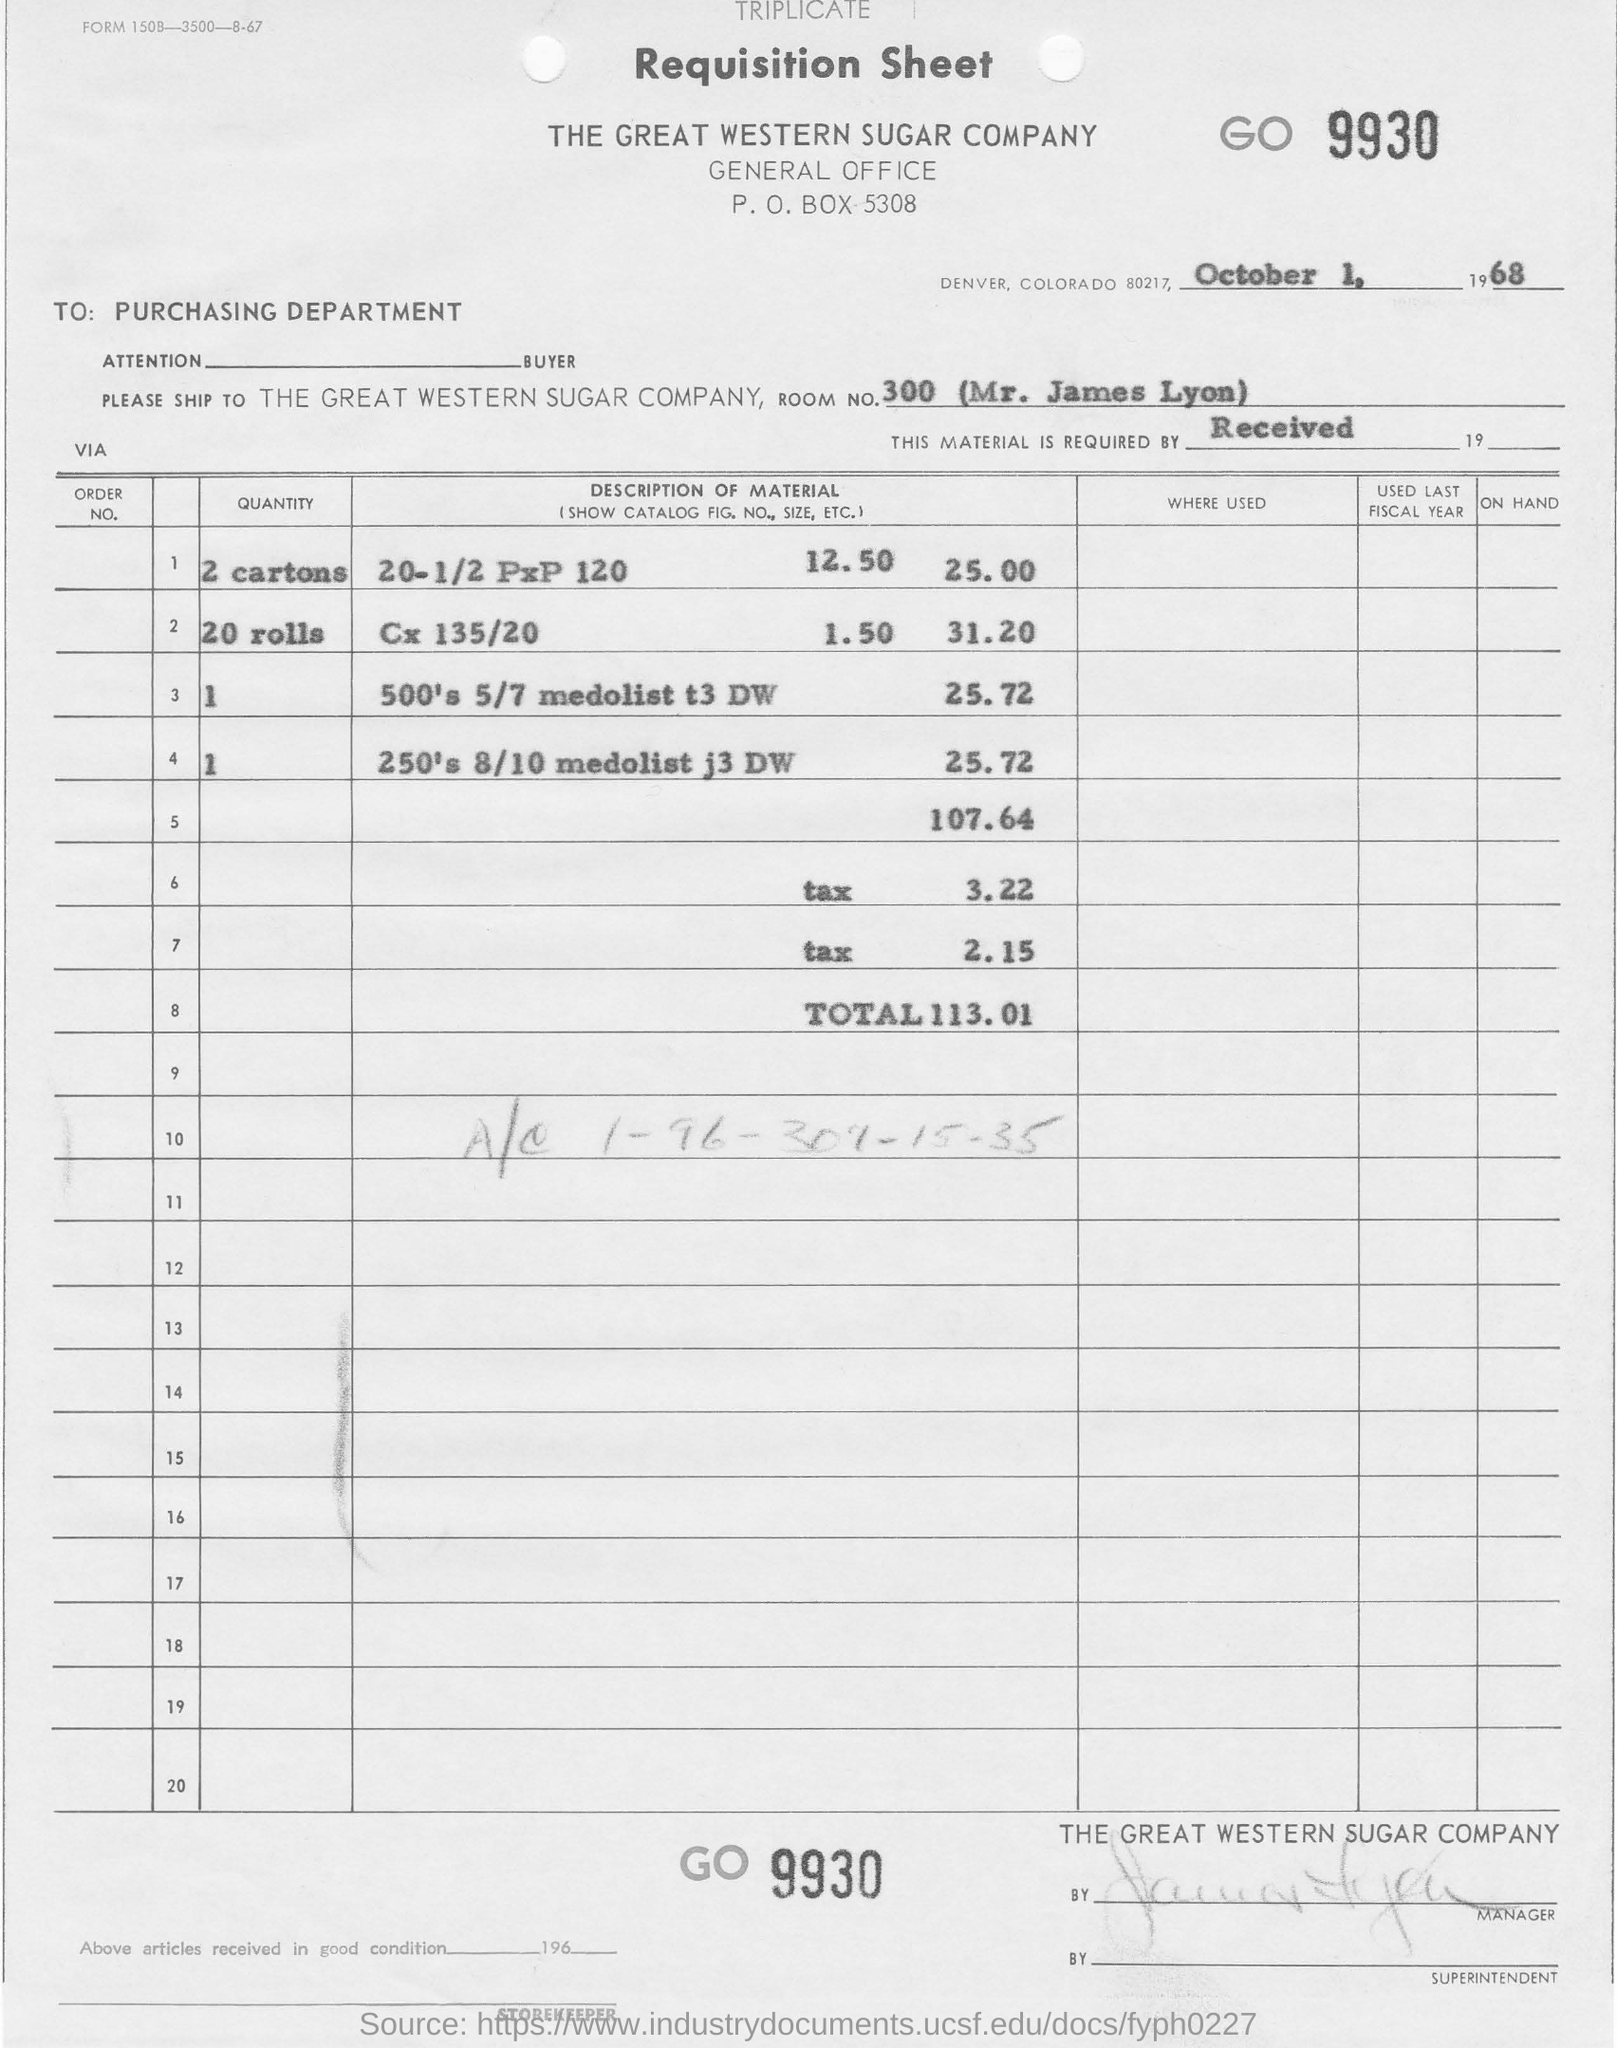Highlight a few significant elements in this photo. The room number mentioned in the sheet is 300. The date on the requisition sheet is October 1, 1968. 